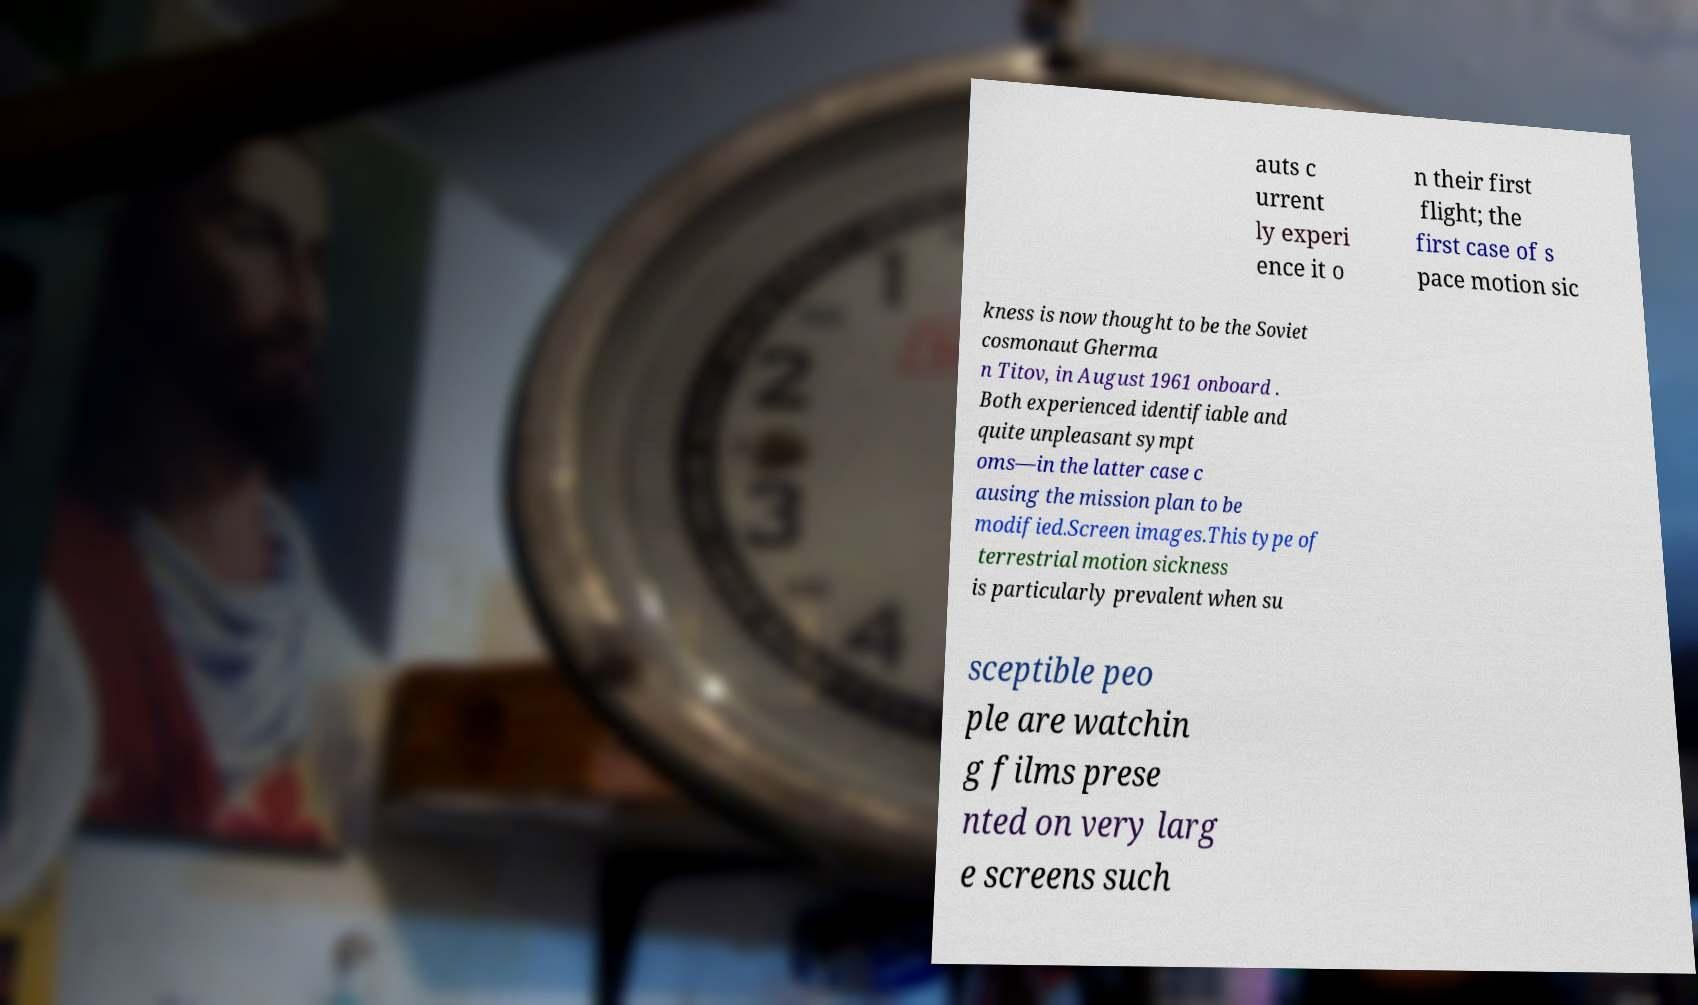Could you assist in decoding the text presented in this image and type it out clearly? auts c urrent ly experi ence it o n their first flight; the first case of s pace motion sic kness is now thought to be the Soviet cosmonaut Gherma n Titov, in August 1961 onboard . Both experienced identifiable and quite unpleasant sympt oms—in the latter case c ausing the mission plan to be modified.Screen images.This type of terrestrial motion sickness is particularly prevalent when su sceptible peo ple are watchin g films prese nted on very larg e screens such 